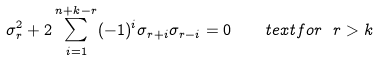Convert formula to latex. <formula><loc_0><loc_0><loc_500><loc_500>\sigma _ { r } ^ { 2 } + 2 \sum _ { i = 1 } ^ { n + k - r } ( - 1 ) ^ { i } \sigma _ { r + i } \sigma _ { r - i } = 0 \quad t e x t { f o r } \ r > k</formula> 